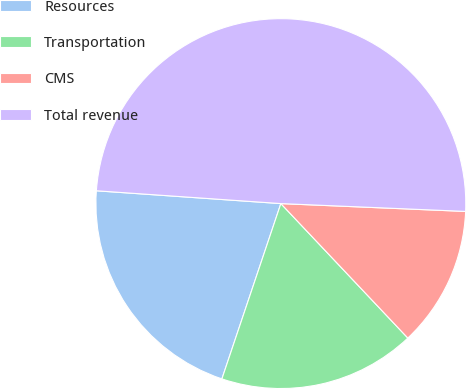Convert chart. <chart><loc_0><loc_0><loc_500><loc_500><pie_chart><fcel>Resources<fcel>Transportation<fcel>CMS<fcel>Total revenue<nl><fcel>20.94%<fcel>17.21%<fcel>12.28%<fcel>49.57%<nl></chart> 